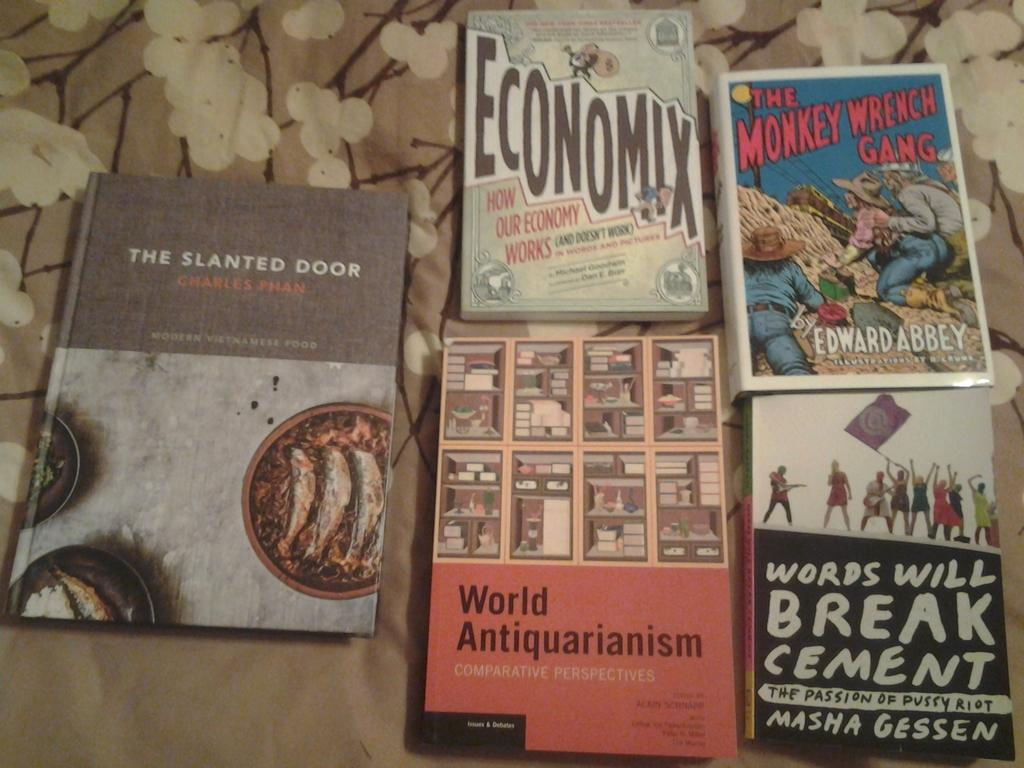<image>
Relay a brief, clear account of the picture shown. Five books, including The Monkey Wrench Gang, lay next to each other. 